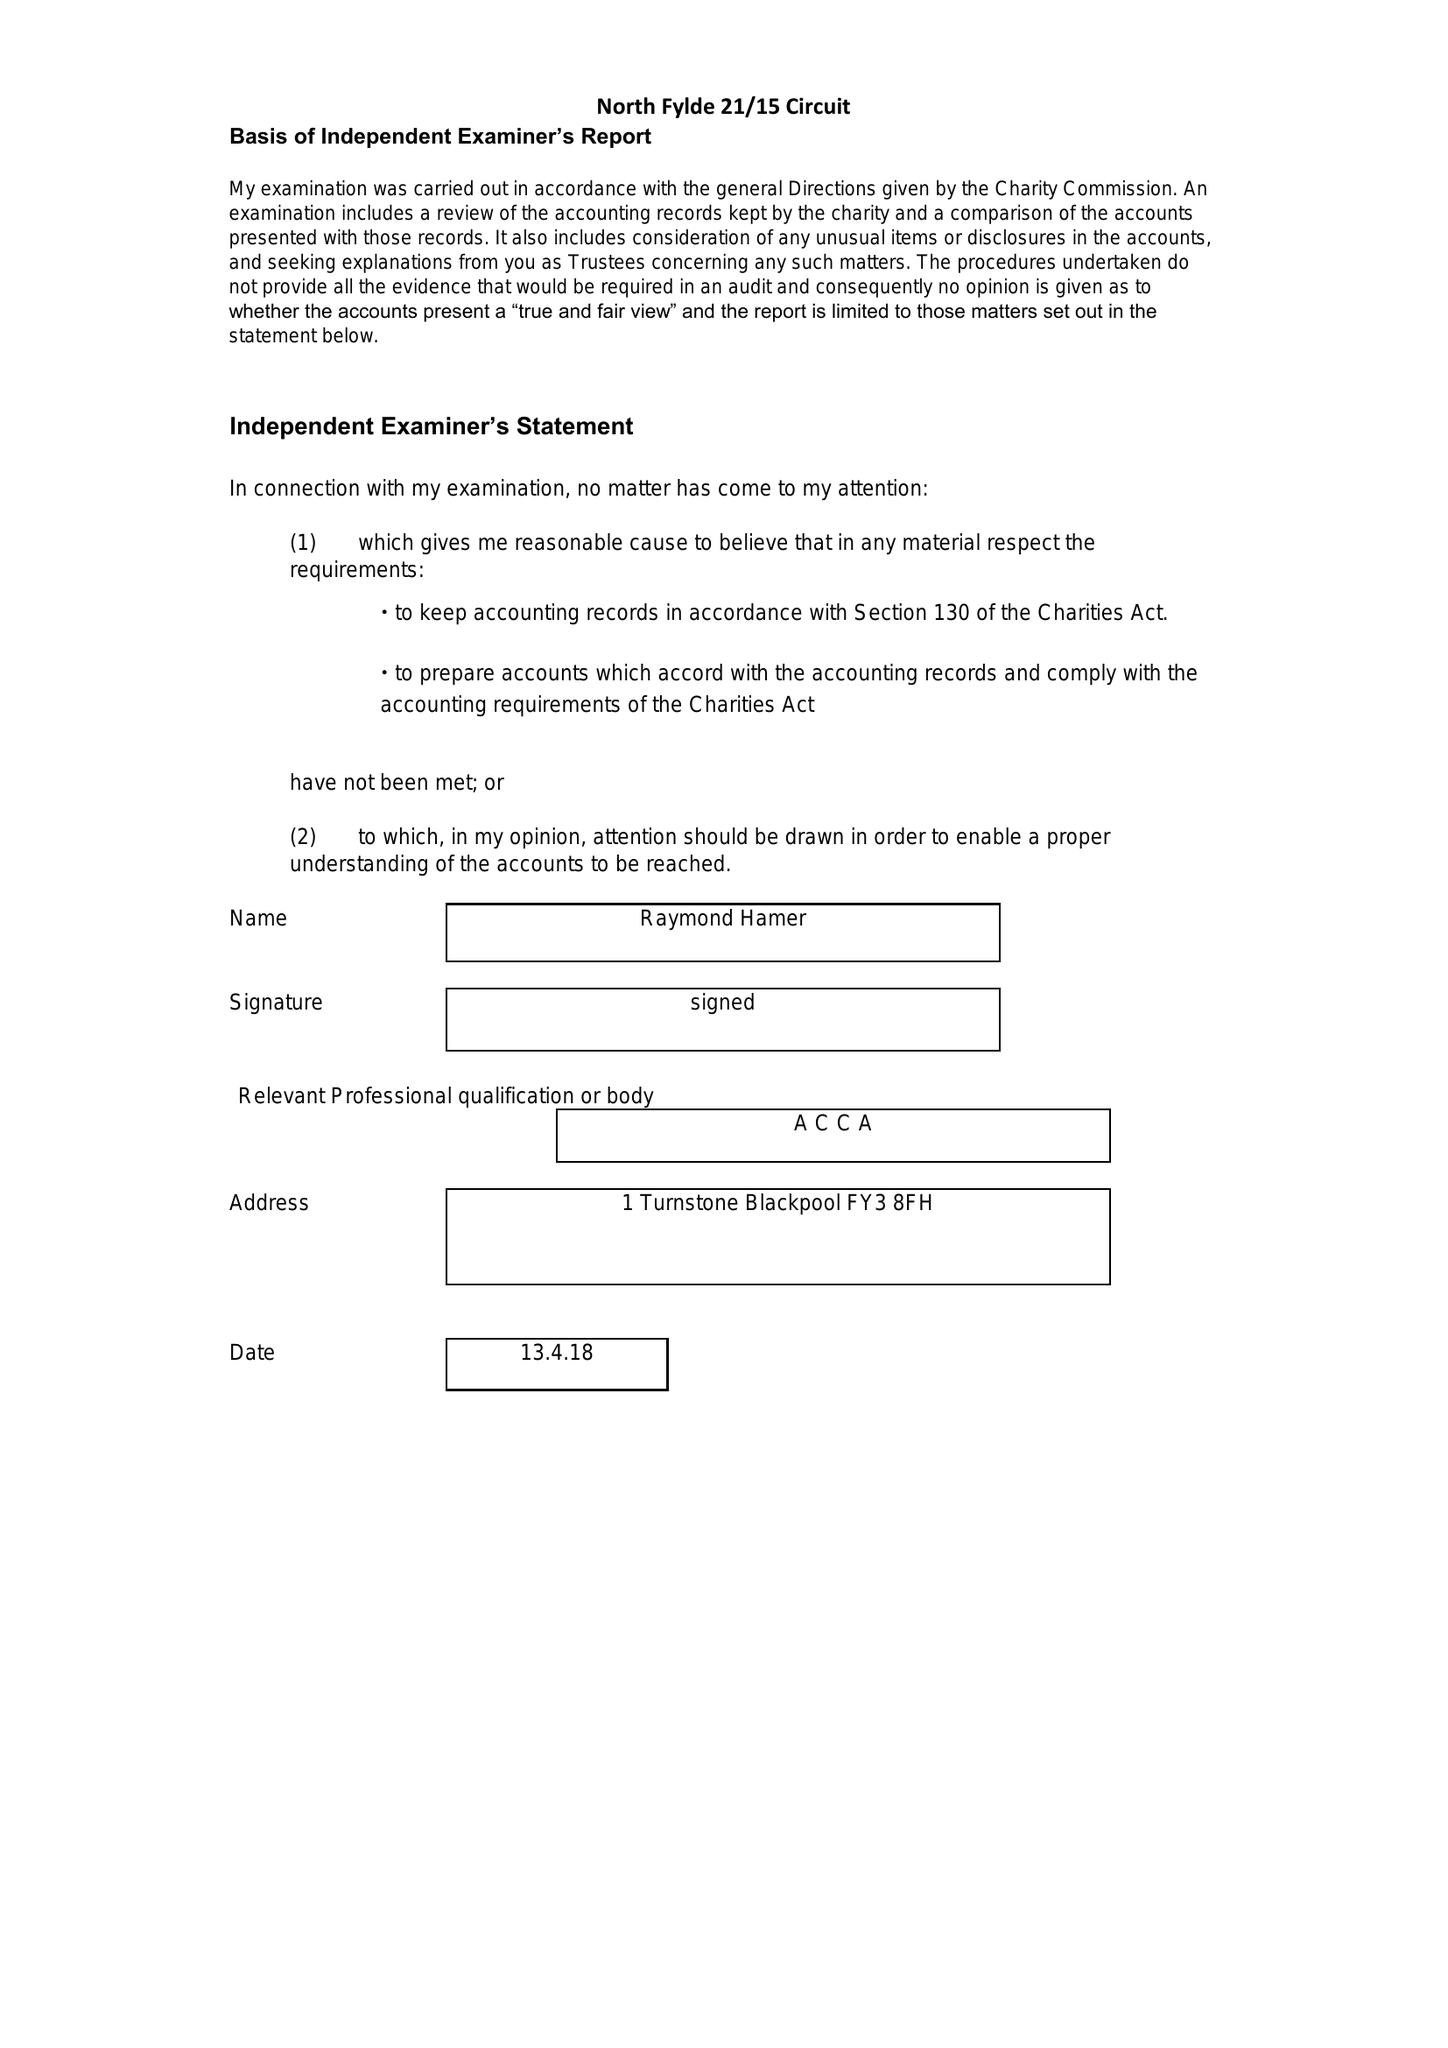What is the value for the charity_number?
Answer the question using a single word or phrase. 1142571 